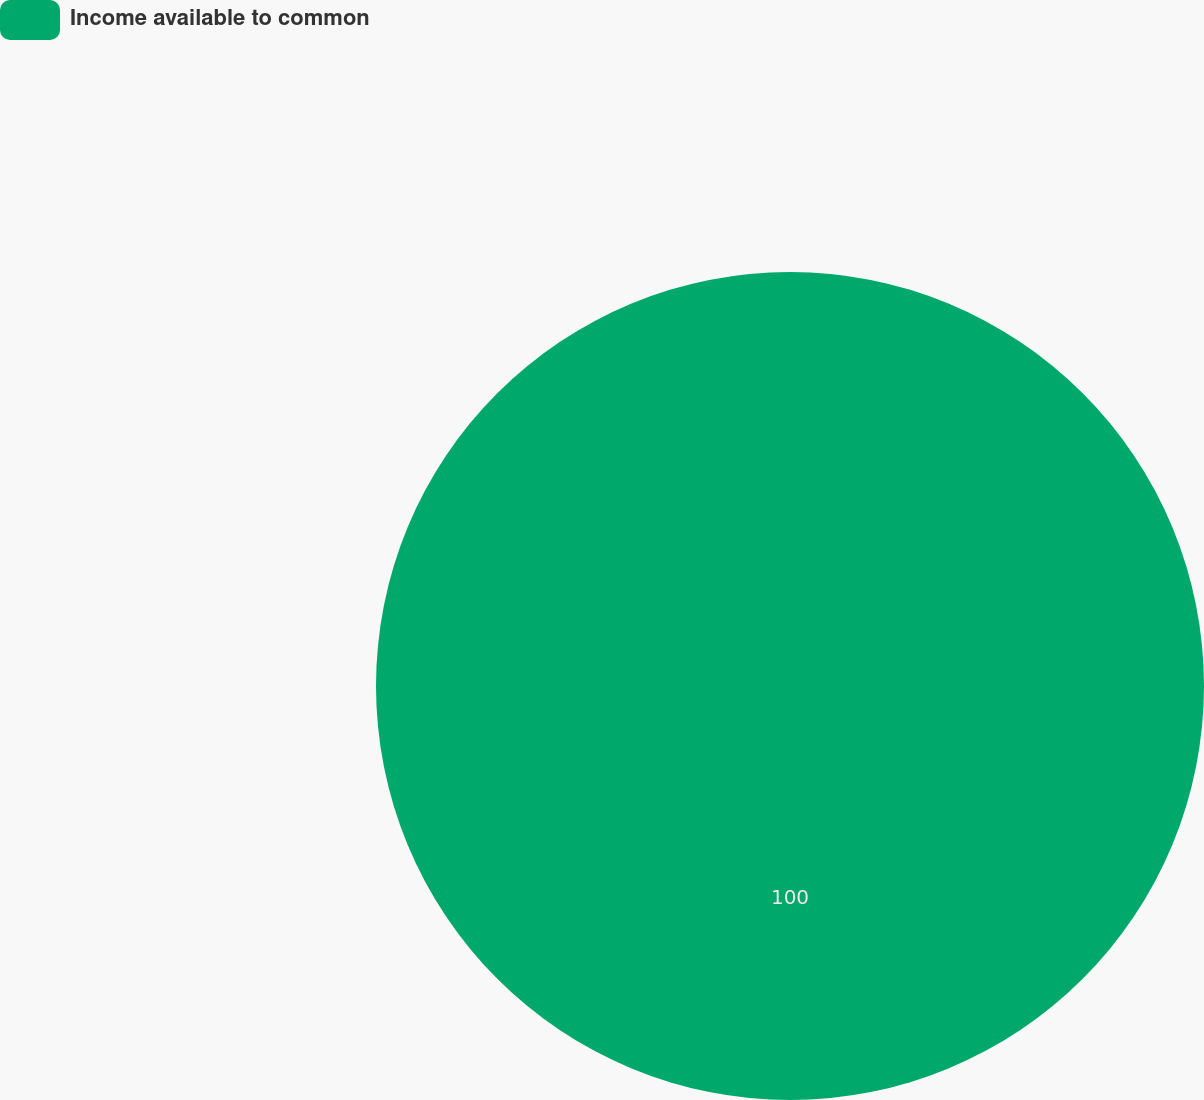<chart> <loc_0><loc_0><loc_500><loc_500><pie_chart><fcel>Income available to common<nl><fcel>100.0%<nl></chart> 